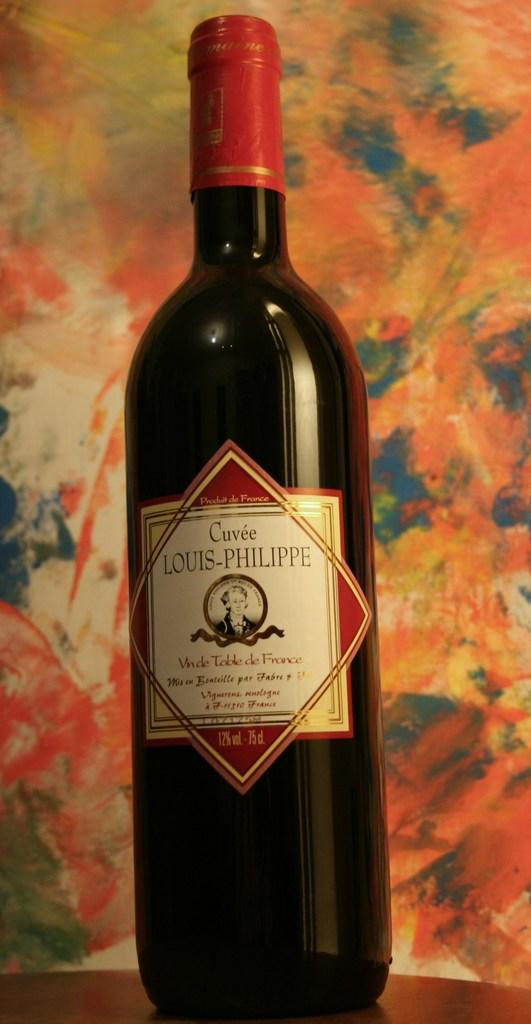<image>
Create a compact narrative representing the image presented. A dark bottle of Louis-Philippe Wine with a red cap is on a colorful background. 